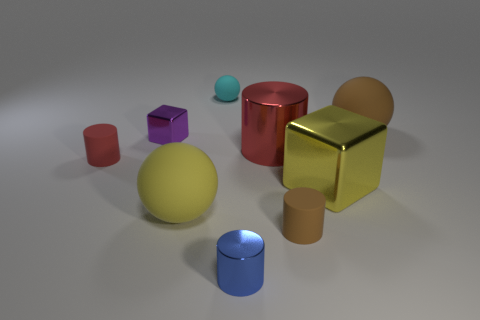What size is the red metal cylinder? The red metal cylinder is medium in size relative to the objects in the image. It is larger than the small blue cylinder and the purple cube but smaller than the gold cube and the yellow sphere. 